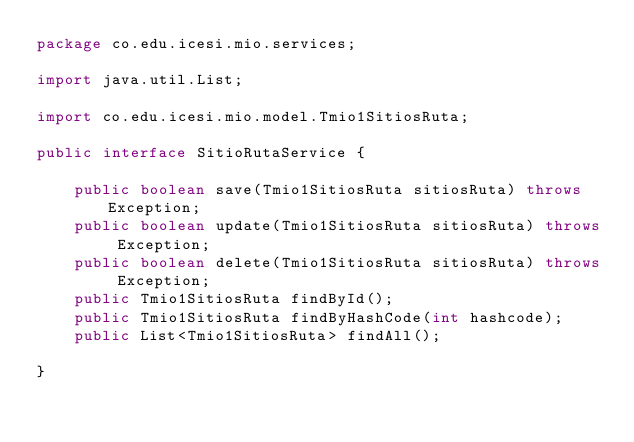Convert code to text. <code><loc_0><loc_0><loc_500><loc_500><_Java_>package co.edu.icesi.mio.services;

import java.util.List;

import co.edu.icesi.mio.model.Tmio1SitiosRuta;

public interface SitioRutaService {
	
	public boolean save(Tmio1SitiosRuta sitiosRuta) throws Exception;
	public boolean update(Tmio1SitiosRuta sitiosRuta) throws Exception;
	public boolean delete(Tmio1SitiosRuta sitiosRuta) throws Exception;
	public Tmio1SitiosRuta findById();
	public Tmio1SitiosRuta findByHashCode(int hashcode);
	public List<Tmio1SitiosRuta> findAll();

}
</code> 